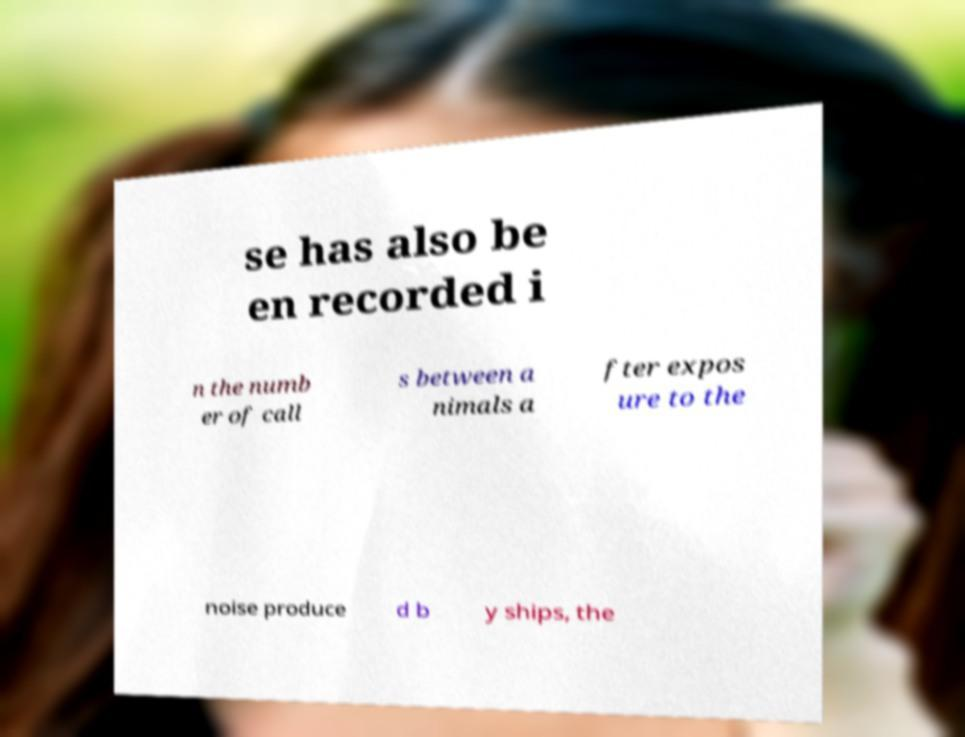Can you accurately transcribe the text from the provided image for me? se has also be en recorded i n the numb er of call s between a nimals a fter expos ure to the noise produce d b y ships, the 